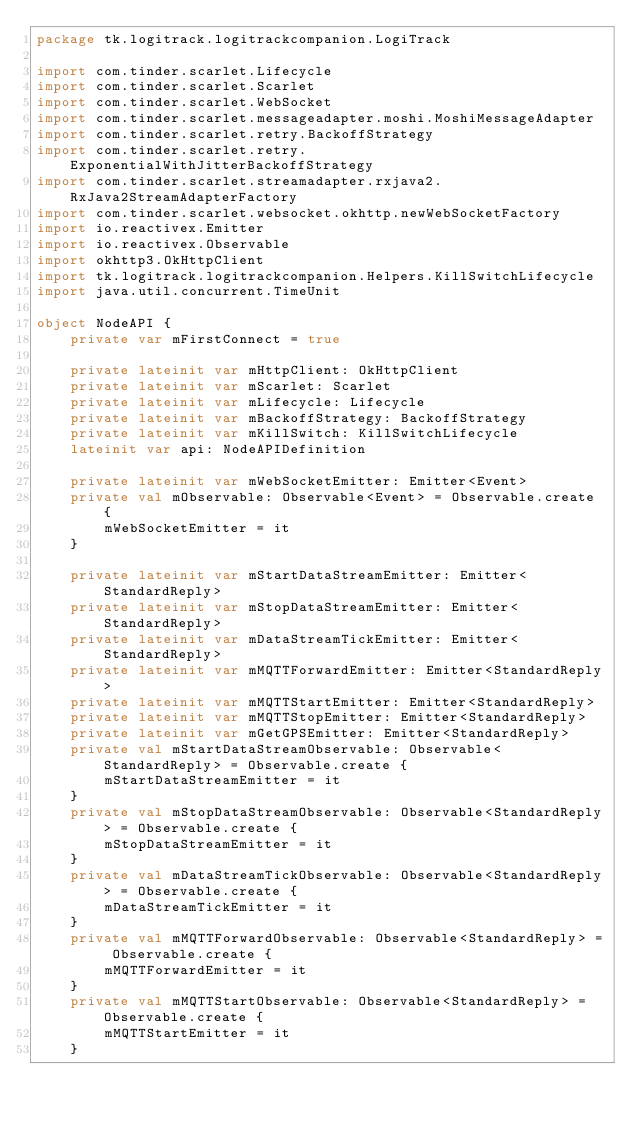<code> <loc_0><loc_0><loc_500><loc_500><_Kotlin_>package tk.logitrack.logitrackcompanion.LogiTrack

import com.tinder.scarlet.Lifecycle
import com.tinder.scarlet.Scarlet
import com.tinder.scarlet.WebSocket
import com.tinder.scarlet.messageadapter.moshi.MoshiMessageAdapter
import com.tinder.scarlet.retry.BackoffStrategy
import com.tinder.scarlet.retry.ExponentialWithJitterBackoffStrategy
import com.tinder.scarlet.streamadapter.rxjava2.RxJava2StreamAdapterFactory
import com.tinder.scarlet.websocket.okhttp.newWebSocketFactory
import io.reactivex.Emitter
import io.reactivex.Observable
import okhttp3.OkHttpClient
import tk.logitrack.logitrackcompanion.Helpers.KillSwitchLifecycle
import java.util.concurrent.TimeUnit

object NodeAPI {
	private var mFirstConnect = true

	private lateinit var mHttpClient: OkHttpClient
	private lateinit var mScarlet: Scarlet
	private lateinit var mLifecycle: Lifecycle
	private lateinit var mBackoffStrategy: BackoffStrategy
	private lateinit var mKillSwitch: KillSwitchLifecycle
	lateinit var api: NodeAPIDefinition

	private lateinit var mWebSocketEmitter: Emitter<Event>
	private val mObservable: Observable<Event> = Observable.create {
		mWebSocketEmitter = it
	}

	private lateinit var mStartDataStreamEmitter: Emitter<StandardReply>
	private lateinit var mStopDataStreamEmitter: Emitter<StandardReply>
	private lateinit var mDataStreamTickEmitter: Emitter<StandardReply>
	private lateinit var mMQTTForwardEmitter: Emitter<StandardReply>
	private lateinit var mMQTTStartEmitter: Emitter<StandardReply>
	private lateinit var mMQTTStopEmitter: Emitter<StandardReply>
	private lateinit var mGetGPSEmitter: Emitter<StandardReply>
	private val mStartDataStreamObservable: Observable<StandardReply> = Observable.create {
		mStartDataStreamEmitter = it
	}
	private val mStopDataStreamObservable: Observable<StandardReply> = Observable.create {
		mStopDataStreamEmitter = it
	}
	private val mDataStreamTickObservable: Observable<StandardReply> = Observable.create {
		mDataStreamTickEmitter = it
	}
	private val mMQTTForwardObservable: Observable<StandardReply> = Observable.create {
		mMQTTForwardEmitter = it
	}
	private val mMQTTStartObservable: Observable<StandardReply> = Observable.create {
		mMQTTStartEmitter = it
	}</code> 